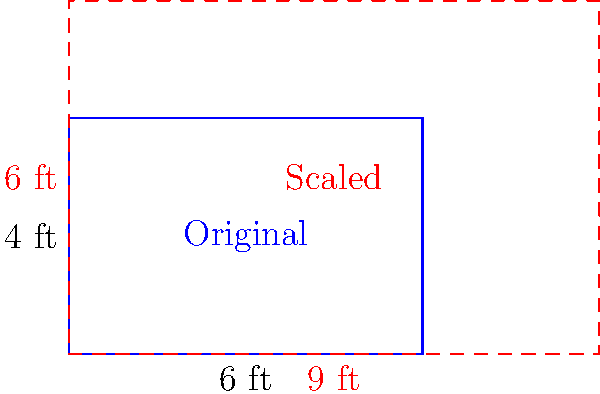You're planning to expand your rectangular herb garden plot. The original plot measures 6 feet by 4 feet. If you want to scale up the garden so that the new length is 9 feet, what will be the area of the new garden plot in square feet? Let's approach this step-by-step:

1) First, we need to determine the scale factor. We can do this by comparing the new length to the original length:
   Scale factor = New length / Original length
   $$ \text{Scale factor} = \frac{9 \text{ ft}}{6 \text{ ft}} = 1.5 $$

2) This scale factor applies to both dimensions of the rectangle. So if the length is scaled by 1.5, the width will also be scaled by 1.5:
   New width = Original width × Scale factor
   $$ \text{New width} = 4 \text{ ft} \times 1.5 = 6 \text{ ft} $$

3) Now we know the dimensions of the new garden plot: 9 ft × 6 ft

4) To find the area, we multiply length by width:
   $$ \text{New Area} = 9 \text{ ft} \times 6 \text{ ft} = 54 \text{ sq ft} $$

5) We can verify this result by comparing it to the original area:
   Original Area = 6 ft × 4 ft = 24 sq ft
   The new area (54 sq ft) is indeed 1.5² = 2.25 times the original area, which is correct for a 2D scaling.
Answer: 54 sq ft 